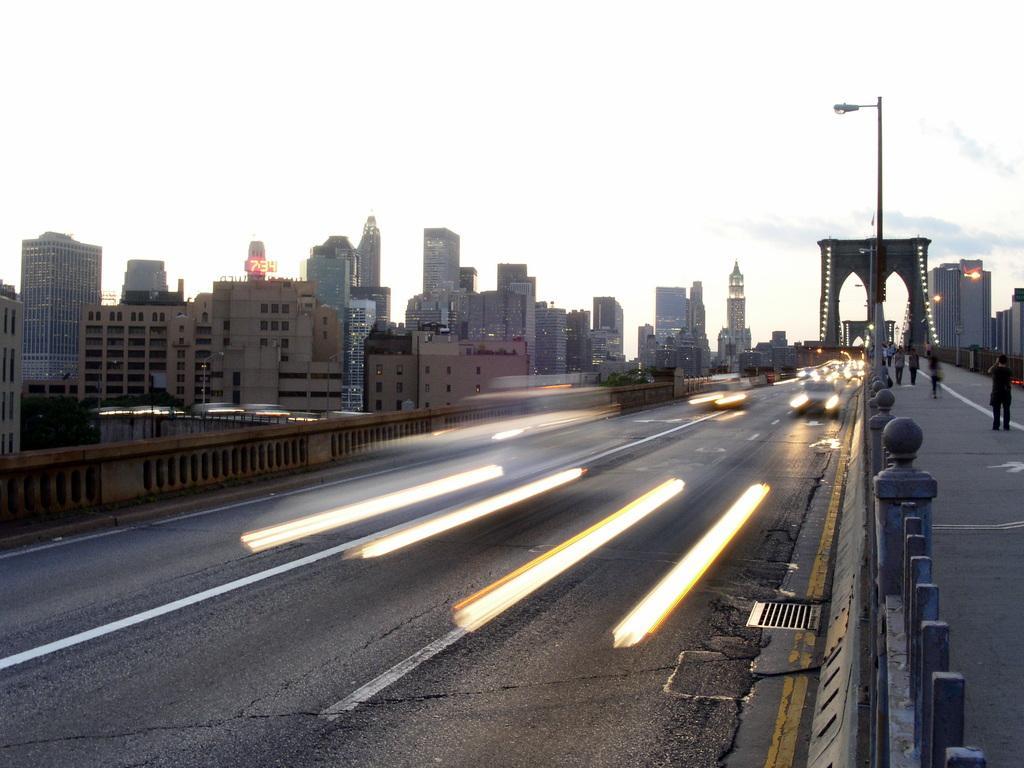Describe this image in one or two sentences. 'In this image, we can see vehicles are moving on the road. On the right side, we can see poles, walkway, few people. Background we can see so many trees, buildings, pillars, towers, poles with lights and sky. 